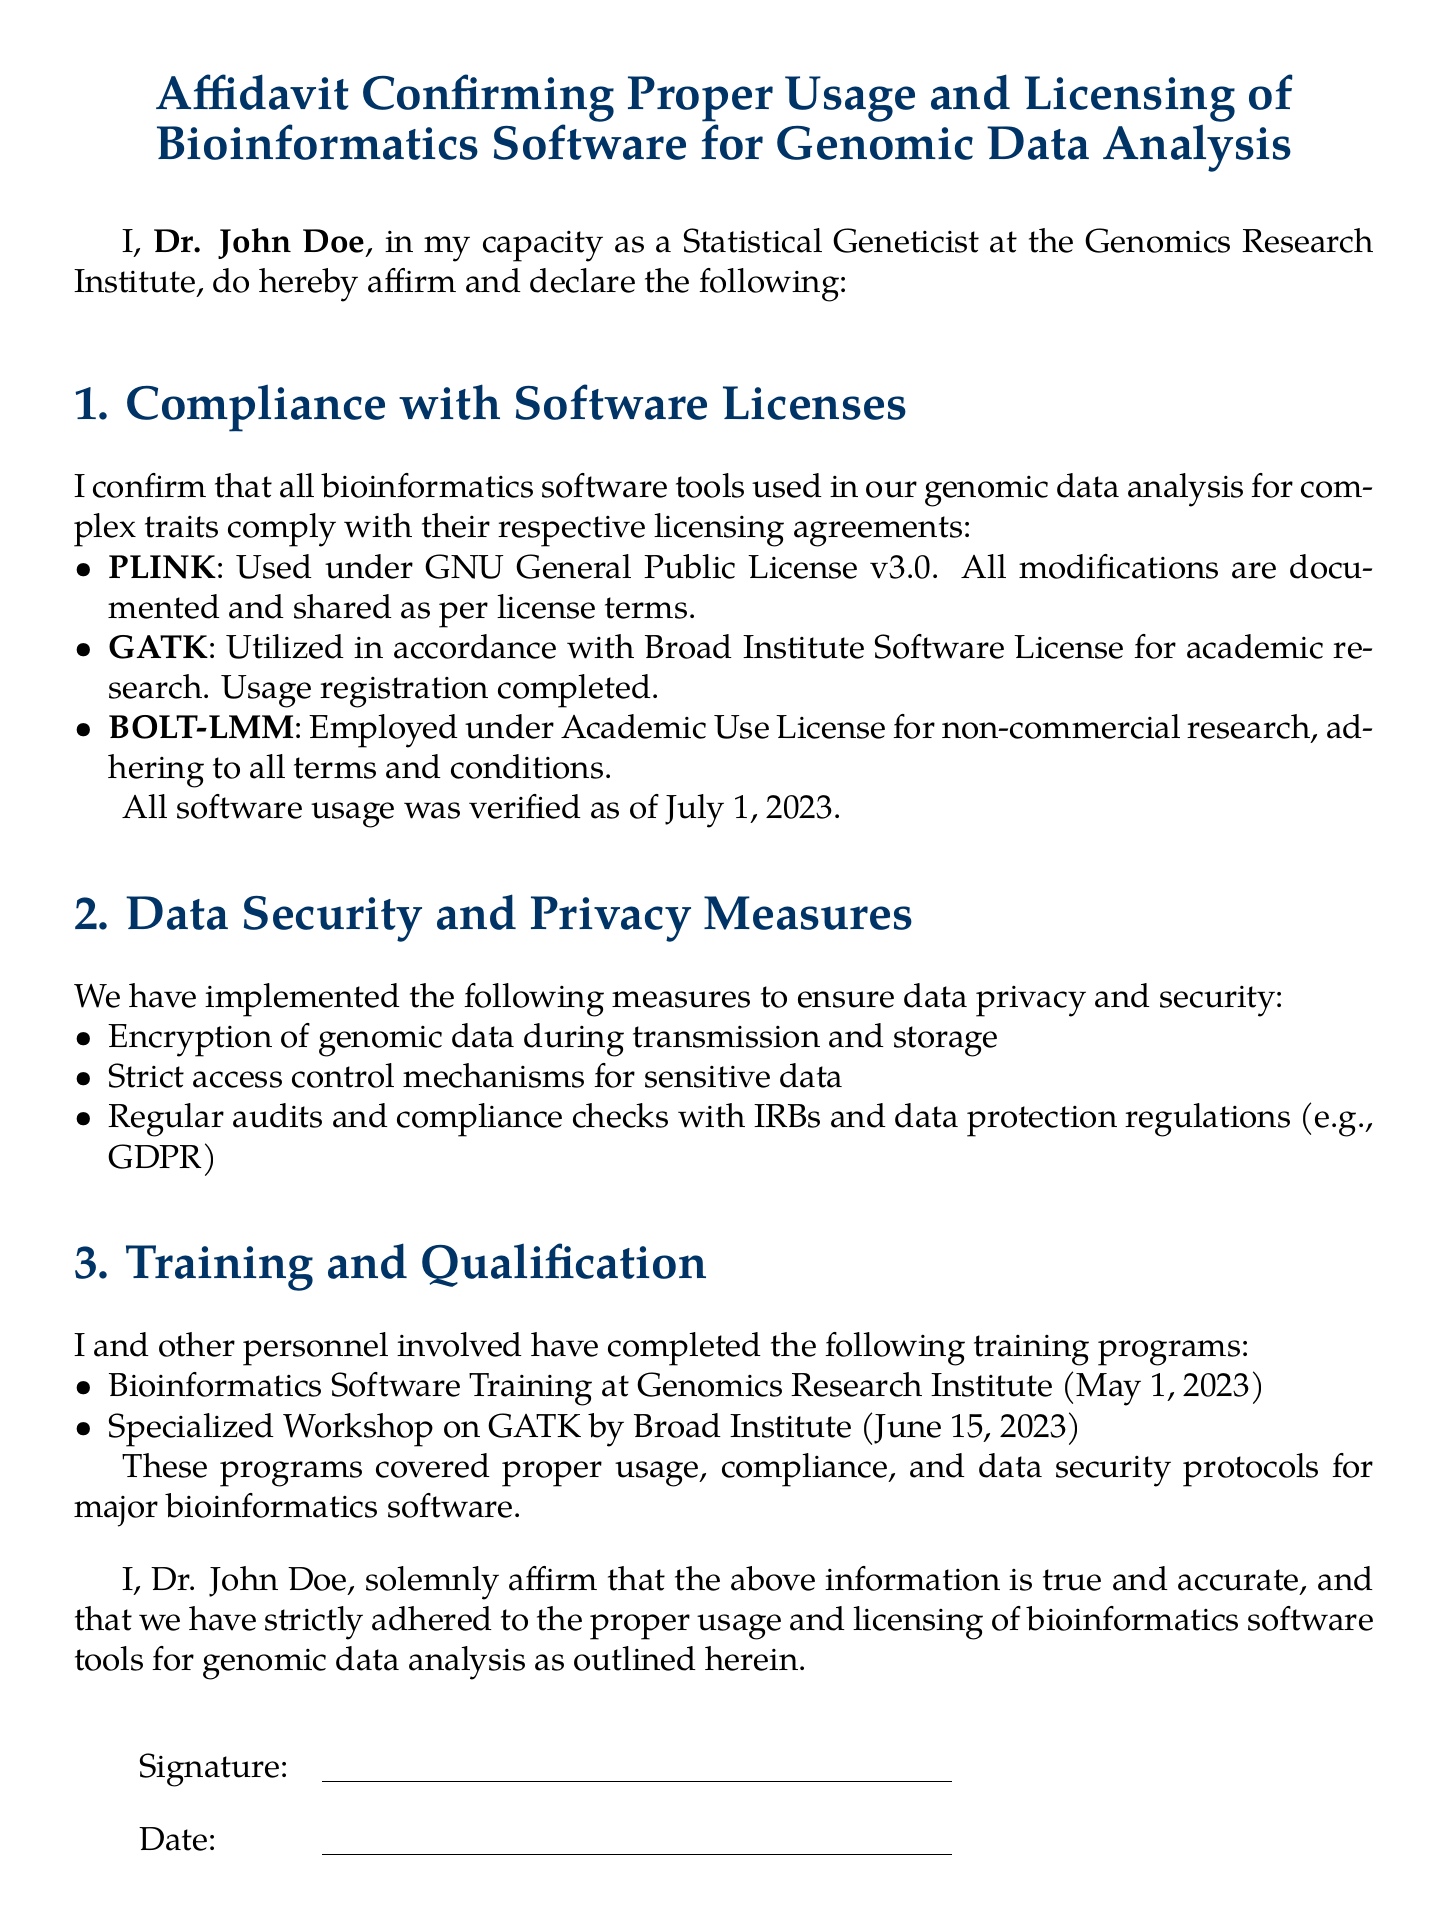What is the name of the affidavit? The title at the beginning of the document specifies the name, which is the Affidavit Confirming Proper Usage and Licensing of Bioinformatics Software for Genomic Data Analysis.
Answer: Affidavit Confirming Proper Usage and Licensing of Bioinformatics Software for Genomic Data Analysis Who is the affiant? The document states that Dr. John Doe is affirming the information in the affidavit.
Answer: Dr. John Doe When was the last verification of software usage? The document mentions the verification date for software usage as July 1, 2023.
Answer: July 1, 2023 What software is used under GNU General Public License v3.0? The document lists PLINK as the software under this license.
Answer: PLINK What type of license is GATK used under? The document indicates that GATK is utilized in accordance with the Broad Institute Software License for academic research.
Answer: Broad Institute Software License for academic research What measures have been implemented for data security? The affidavit lists several measures, including encryption of genomic data, access control mechanisms, and audits with IRBs and regulations.
Answer: Encryption, access control, audits What training program was completed on May 1, 2023? The document specifies that Bioinformatics Software Training at Genomics Research Institute was completed on this date.
Answer: Bioinformatics Software Training at Genomics Research Institute How many training programs are mentioned? The document outlines two training programs completed by the personnel involved.
Answer: Two 